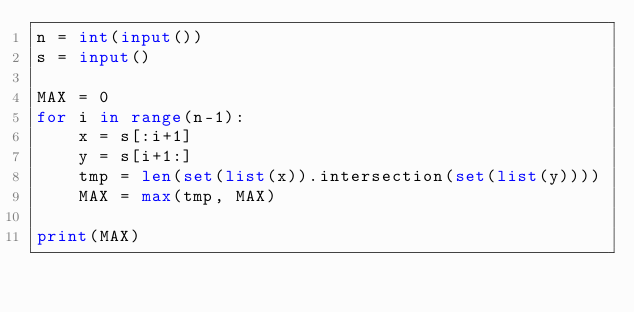Convert code to text. <code><loc_0><loc_0><loc_500><loc_500><_Python_>n = int(input())
s = input()

MAX = 0
for i in range(n-1):
    x = s[:i+1]
    y = s[i+1:]
    tmp = len(set(list(x)).intersection(set(list(y))))
    MAX = max(tmp, MAX)

print(MAX)</code> 